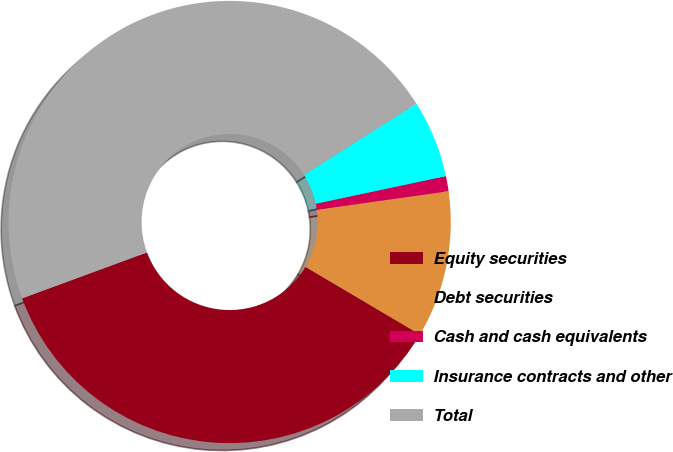Convert chart to OTSL. <chart><loc_0><loc_0><loc_500><loc_500><pie_chart><fcel>Equity securities<fcel>Debt securities<fcel>Cash and cash equivalents<fcel>Insurance contracts and other<fcel>Total<nl><fcel>35.89%<fcel>10.72%<fcel>1.11%<fcel>5.66%<fcel>46.61%<nl></chart> 